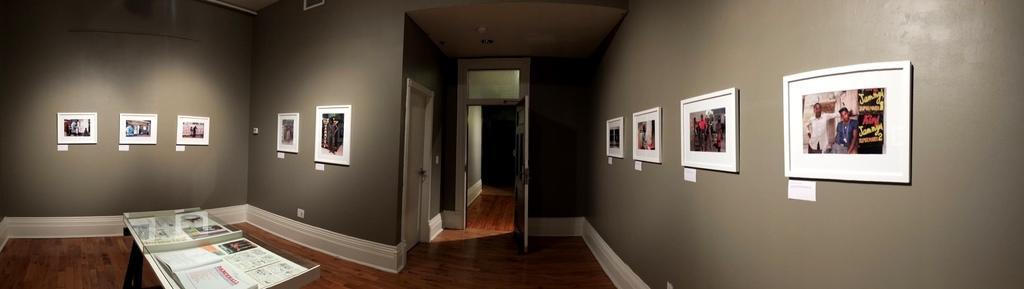Can you describe this image briefly? This image is taken in the room. In this image there are photo frames placed on the walls. On the left there is a table and we can see a book and newspapers placed on the table. We can see doors. At the bottom there is a floor. 